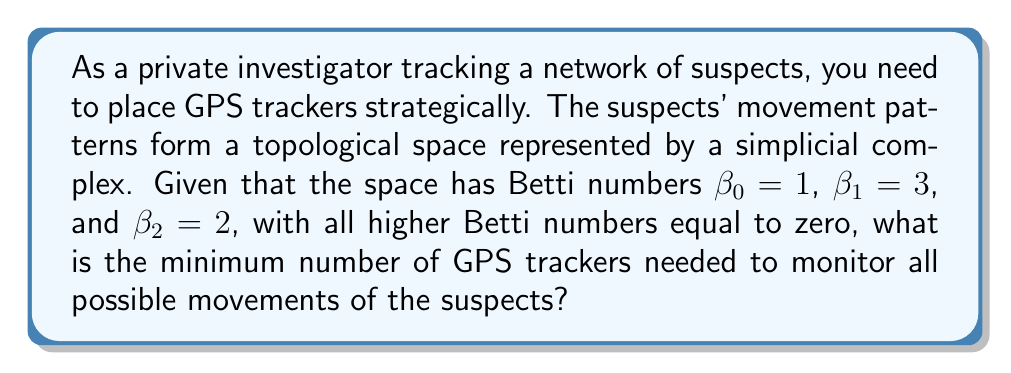Show me your answer to this math problem. To solve this problem, we need to understand the concept of Betti numbers in topology and their relation to the minimum number of "sensors" (in this case, GPS trackers) needed to monitor a topological space.

1) Betti numbers represent the number of independent n-dimensional holes in a topological space:
   - $\beta_0$: number of connected components
   - $\beta_1$: number of 1-dimensional holes (loops)
   - $\beta_2$: number of 2-dimensional holes (voids)
   - Higher Betti numbers represent higher-dimensional holes

2) The minimum number of sensors needed is related to the sum of the Betti numbers. This is because:
   - We need at least one sensor for each connected component ($\beta_0$)
   - We need additional sensors to "close" each loop ($\beta_1$)
   - We need sensors to "enclose" each void ($\beta_2$)
   - This pattern continues for higher-dimensional holes

3) The formula for the minimum number of sensors is:

   $$\text{Minimum Sensors} = 1 + \sum_{i=0}^{\infty} \beta_i$$

4) In this case, we have:
   $\beta_0 = 1$
   $\beta_1 = 3$
   $\beta_2 = 2$
   All higher Betti numbers are zero

5) Applying the formula:
   $$\text{Minimum Sensors} = 1 + (1 + 3 + 2) = 1 + 6 = 7$$

Therefore, the minimum number of GPS trackers needed is 7.
Answer: 7 GPS trackers 